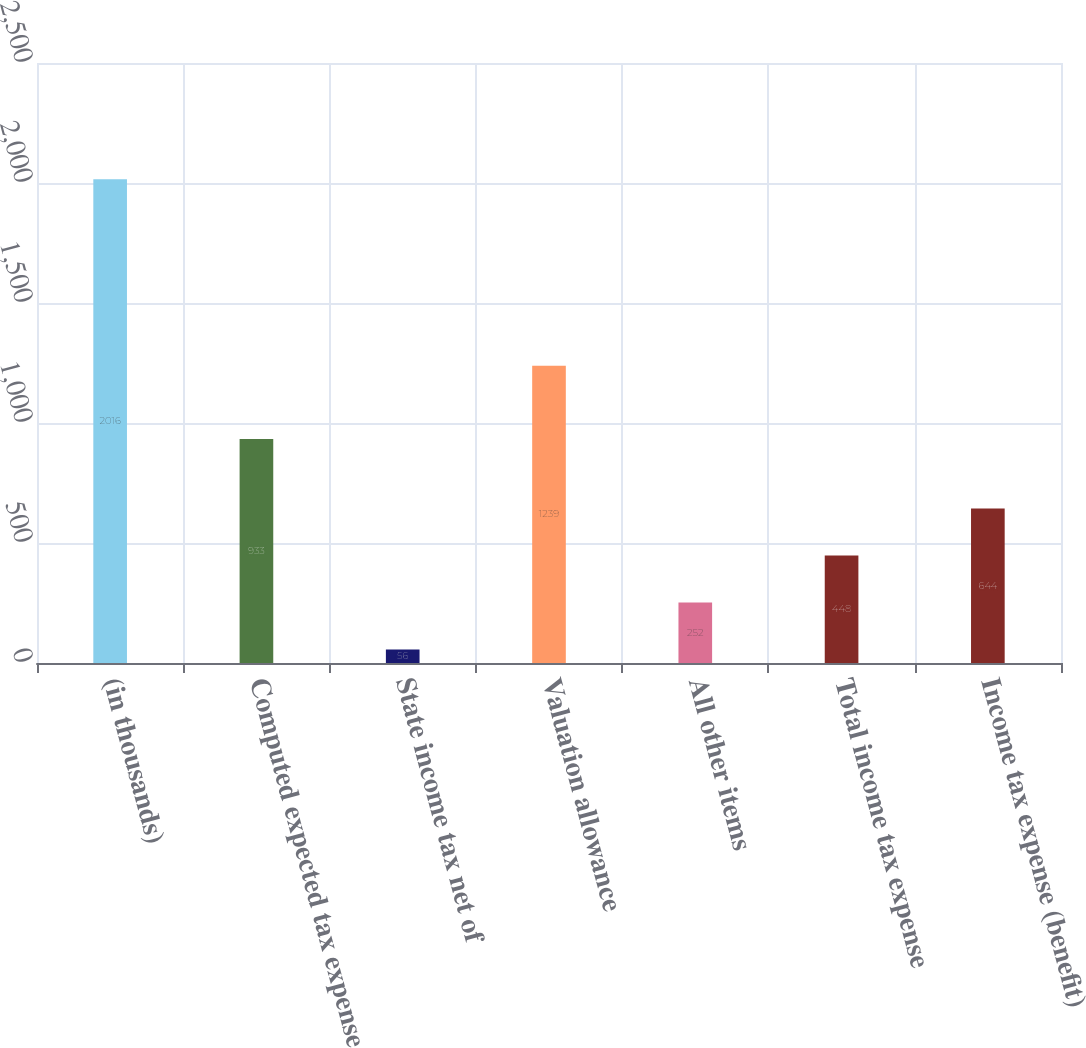<chart> <loc_0><loc_0><loc_500><loc_500><bar_chart><fcel>(in thousands)<fcel>Computed expected tax expense<fcel>State income tax net of<fcel>Valuation allowance<fcel>All other items<fcel>Total income tax expense<fcel>Income tax expense (benefit)<nl><fcel>2016<fcel>933<fcel>56<fcel>1239<fcel>252<fcel>448<fcel>644<nl></chart> 